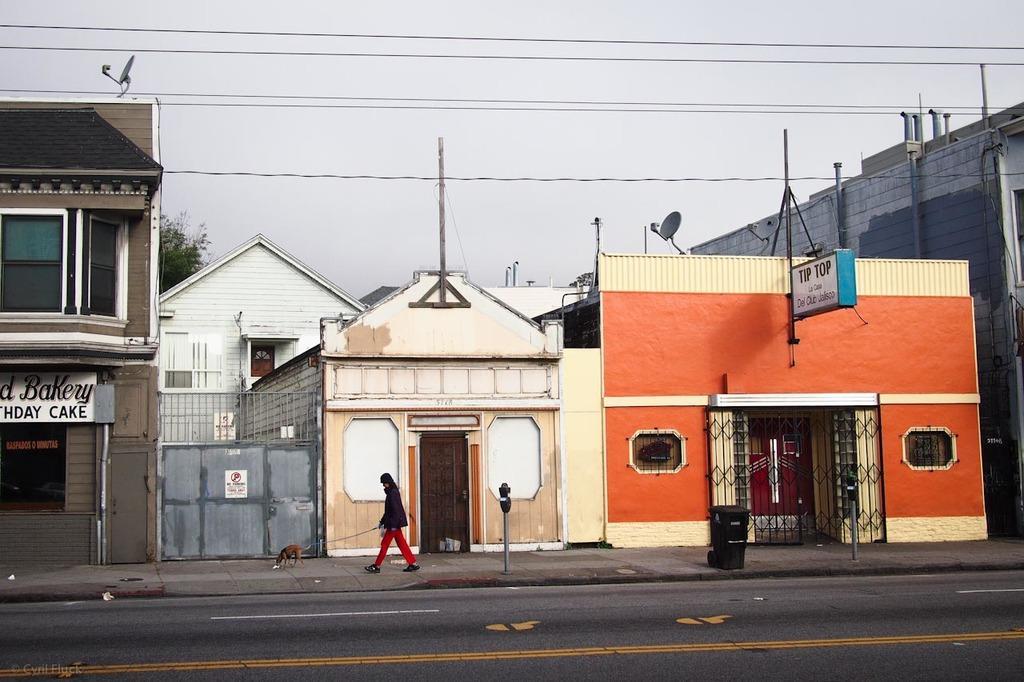In one or two sentences, can you explain what this image depicts? In this picture I can see buildings and a man is walking with the dog on the side of a road. Here I can see poles which has wires and some other objects on the ground. In the background I can see a tree and the sky. 